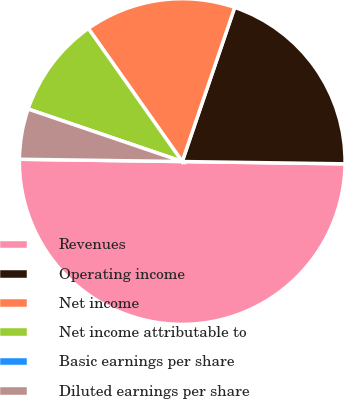<chart> <loc_0><loc_0><loc_500><loc_500><pie_chart><fcel>Revenues<fcel>Operating income<fcel>Net income<fcel>Net income attributable to<fcel>Basic earnings per share<fcel>Diluted earnings per share<nl><fcel>50.0%<fcel>20.0%<fcel>15.0%<fcel>10.0%<fcel>0.0%<fcel>5.0%<nl></chart> 